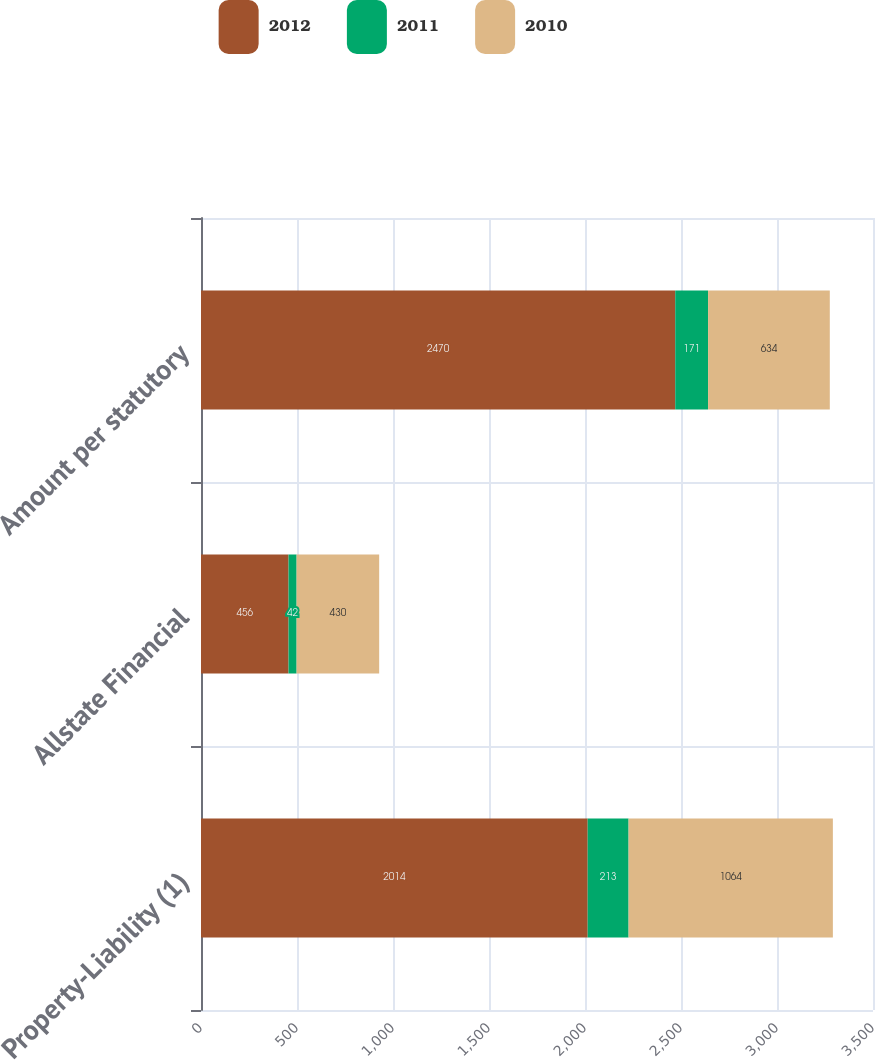Convert chart to OTSL. <chart><loc_0><loc_0><loc_500><loc_500><stacked_bar_chart><ecel><fcel>Property-Liability (1)<fcel>Allstate Financial<fcel>Amount per statutory<nl><fcel>2012<fcel>2014<fcel>456<fcel>2470<nl><fcel>2011<fcel>213<fcel>42<fcel>171<nl><fcel>2010<fcel>1064<fcel>430<fcel>634<nl></chart> 